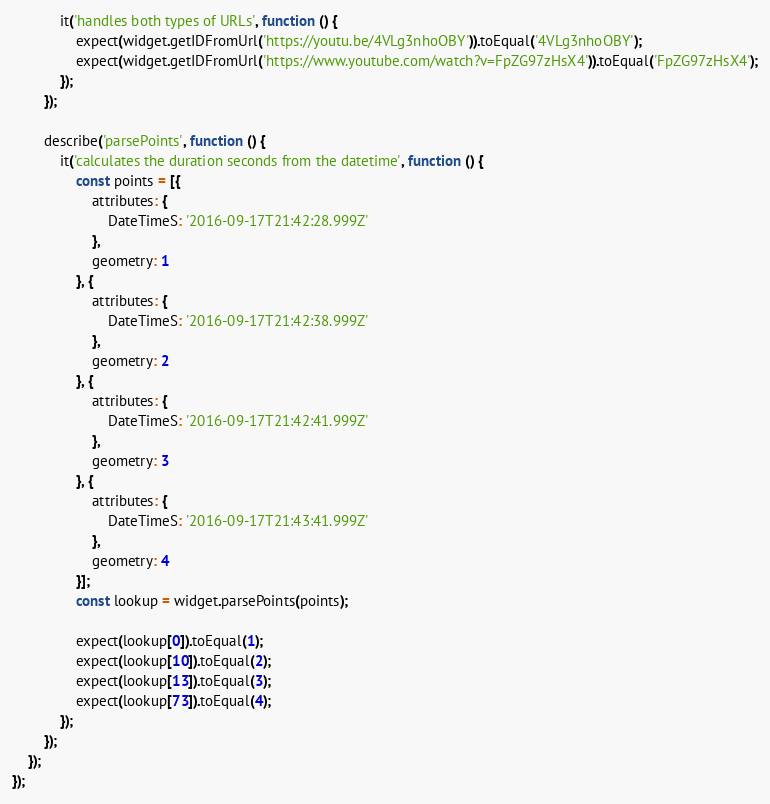Convert code to text. <code><loc_0><loc_0><loc_500><loc_500><_JavaScript_>            it('handles both types of URLs', function () {
                expect(widget.getIDFromUrl('https://youtu.be/4VLg3nhoOBY')).toEqual('4VLg3nhoOBY');
                expect(widget.getIDFromUrl('https://www.youtube.com/watch?v=FpZG97zHsX4')).toEqual('FpZG97zHsX4');
            });
        });

        describe('parsePoints', function () {
            it('calculates the duration seconds from the datetime', function () {
                const points = [{
                    attributes: {
                        DateTimeS: '2016-09-17T21:42:28.999Z'
                    },
                    geometry: 1
                }, {
                    attributes: {
                        DateTimeS: '2016-09-17T21:42:38.999Z'
                    },
                    geometry: 2
                }, {
                    attributes: {
                        DateTimeS: '2016-09-17T21:42:41.999Z'
                    },
                    geometry: 3
                }, {
                    attributes: {
                        DateTimeS: '2016-09-17T21:43:41.999Z'
                    },
                    geometry: 4
                }];
                const lookup = widget.parsePoints(points);

                expect(lookup[0]).toEqual(1);
                expect(lookup[10]).toEqual(2);
                expect(lookup[13]).toEqual(3);
                expect(lookup[73]).toEqual(4);
            });
        });
    });
});
</code> 